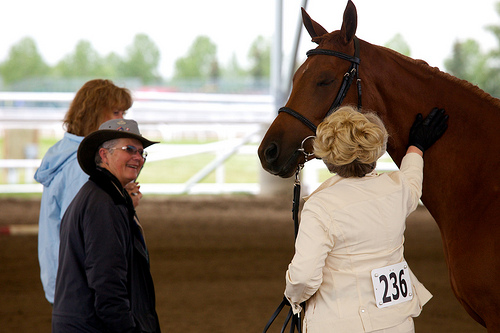<image>
Is there a women on the horse? No. The women is not positioned on the horse. They may be near each other, but the women is not supported by or resting on top of the horse. Where is the horse in relation to the woman? Is it on the woman? No. The horse is not positioned on the woman. They may be near each other, but the horse is not supported by or resting on top of the woman. Is there a horse behind the woman? No. The horse is not behind the woman. From this viewpoint, the horse appears to be positioned elsewhere in the scene. 